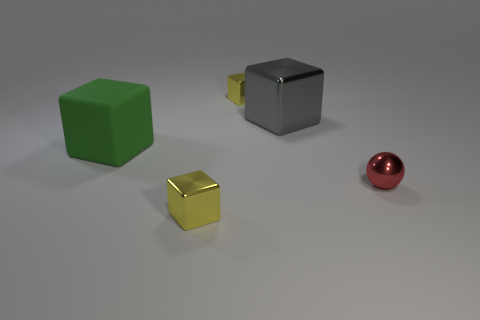Add 1 tiny yellow blocks. How many objects exist? 6 Subtract all blocks. How many objects are left? 1 Subtract 0 green balls. How many objects are left? 5 Subtract all big green objects. Subtract all gray things. How many objects are left? 3 Add 1 tiny cubes. How many tiny cubes are left? 3 Add 5 green things. How many green things exist? 6 